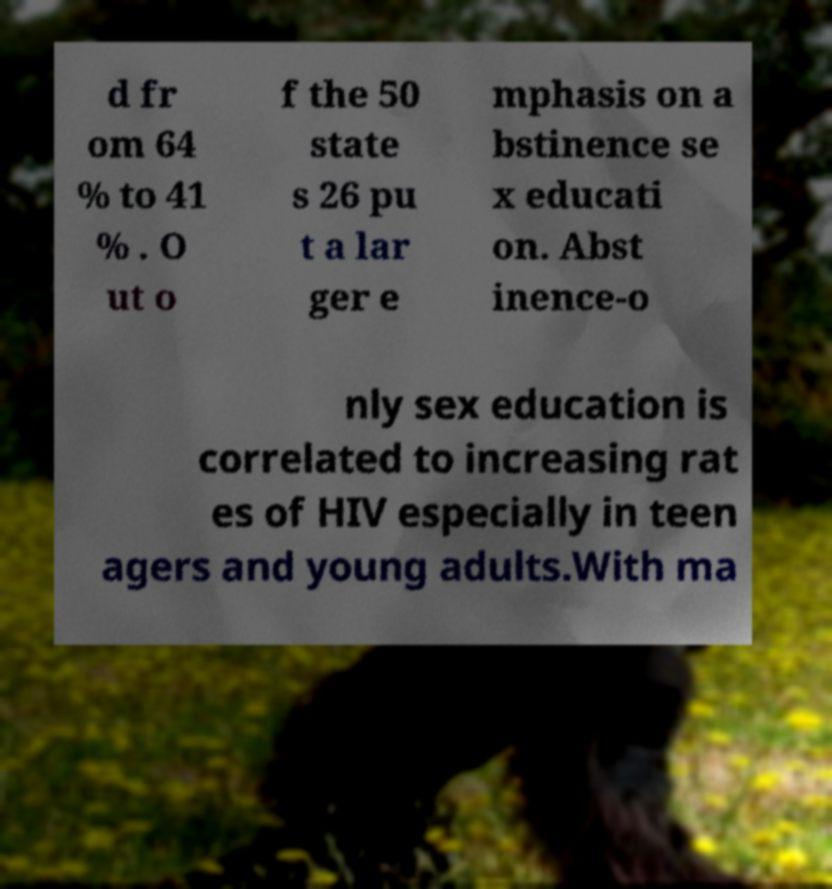Could you assist in decoding the text presented in this image and type it out clearly? d fr om 64 % to 41 % . O ut o f the 50 state s 26 pu t a lar ger e mphasis on a bstinence se x educati on. Abst inence-o nly sex education is correlated to increasing rat es of HIV especially in teen agers and young adults.With ma 